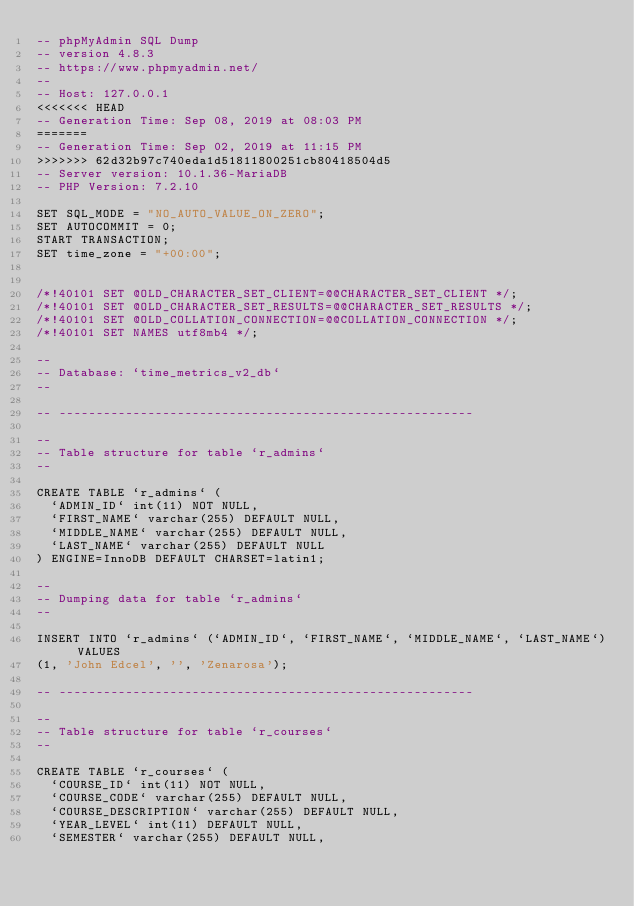<code> <loc_0><loc_0><loc_500><loc_500><_SQL_>-- phpMyAdmin SQL Dump
-- version 4.8.3
-- https://www.phpmyadmin.net/
--
-- Host: 127.0.0.1
<<<<<<< HEAD
-- Generation Time: Sep 08, 2019 at 08:03 PM
=======
-- Generation Time: Sep 02, 2019 at 11:15 PM
>>>>>>> 62d32b97c740eda1d51811800251cb80418504d5
-- Server version: 10.1.36-MariaDB
-- PHP Version: 7.2.10

SET SQL_MODE = "NO_AUTO_VALUE_ON_ZERO";
SET AUTOCOMMIT = 0;
START TRANSACTION;
SET time_zone = "+00:00";


/*!40101 SET @OLD_CHARACTER_SET_CLIENT=@@CHARACTER_SET_CLIENT */;
/*!40101 SET @OLD_CHARACTER_SET_RESULTS=@@CHARACTER_SET_RESULTS */;
/*!40101 SET @OLD_COLLATION_CONNECTION=@@COLLATION_CONNECTION */;
/*!40101 SET NAMES utf8mb4 */;

--
-- Database: `time_metrics_v2_db`
--

-- --------------------------------------------------------

--
-- Table structure for table `r_admins`
--

CREATE TABLE `r_admins` (
  `ADMIN_ID` int(11) NOT NULL,
  `FIRST_NAME` varchar(255) DEFAULT NULL,
  `MIDDLE_NAME` varchar(255) DEFAULT NULL,
  `LAST_NAME` varchar(255) DEFAULT NULL
) ENGINE=InnoDB DEFAULT CHARSET=latin1;

--
-- Dumping data for table `r_admins`
--

INSERT INTO `r_admins` (`ADMIN_ID`, `FIRST_NAME`, `MIDDLE_NAME`, `LAST_NAME`) VALUES
(1, 'John Edcel', '', 'Zenarosa');

-- --------------------------------------------------------

--
-- Table structure for table `r_courses`
--

CREATE TABLE `r_courses` (
  `COURSE_ID` int(11) NOT NULL,
  `COURSE_CODE` varchar(255) DEFAULT NULL,
  `COURSE_DESCRIPTION` varchar(255) DEFAULT NULL,
  `YEAR_LEVEL` int(11) DEFAULT NULL,
  `SEMESTER` varchar(255) DEFAULT NULL,</code> 